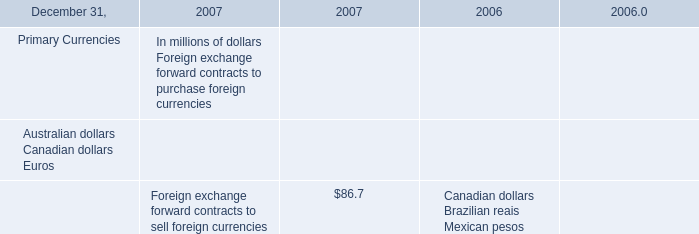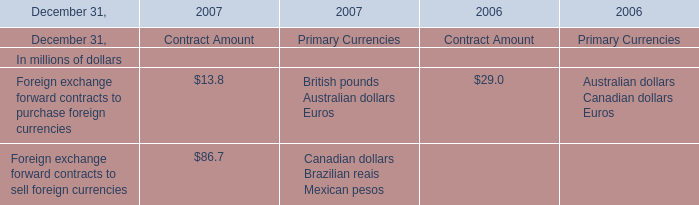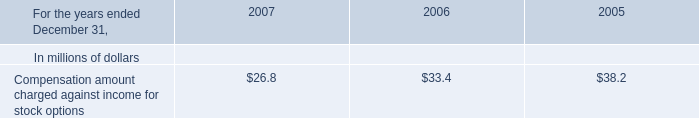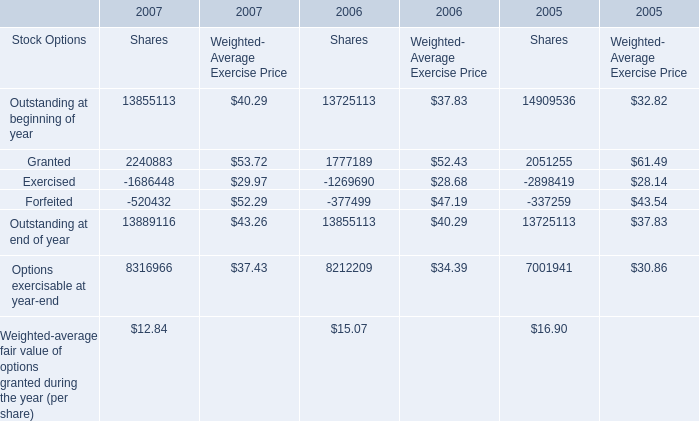In the year with lowest amount of Compensation amount charged against income for stock options, what's the increasing rate of Foreign exchange forward contracts to purchase foreign currencies? (in million) 
Computations: ((13.8 - 29) / 29)
Answer: -0.52414. 